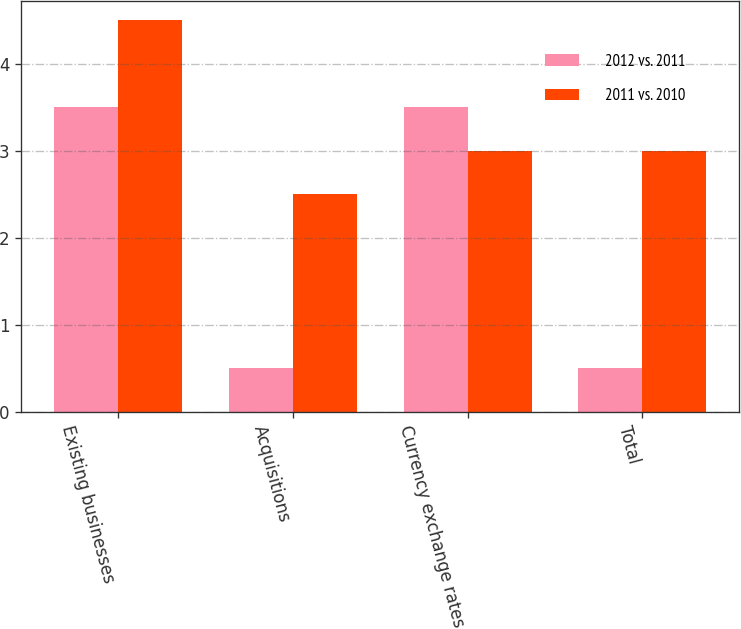<chart> <loc_0><loc_0><loc_500><loc_500><stacked_bar_chart><ecel><fcel>Existing businesses<fcel>Acquisitions<fcel>Currency exchange rates<fcel>Total<nl><fcel>2012 vs. 2011<fcel>3.5<fcel>0.5<fcel>3.5<fcel>0.5<nl><fcel>2011 vs. 2010<fcel>4.5<fcel>2.5<fcel>3<fcel>3<nl></chart> 